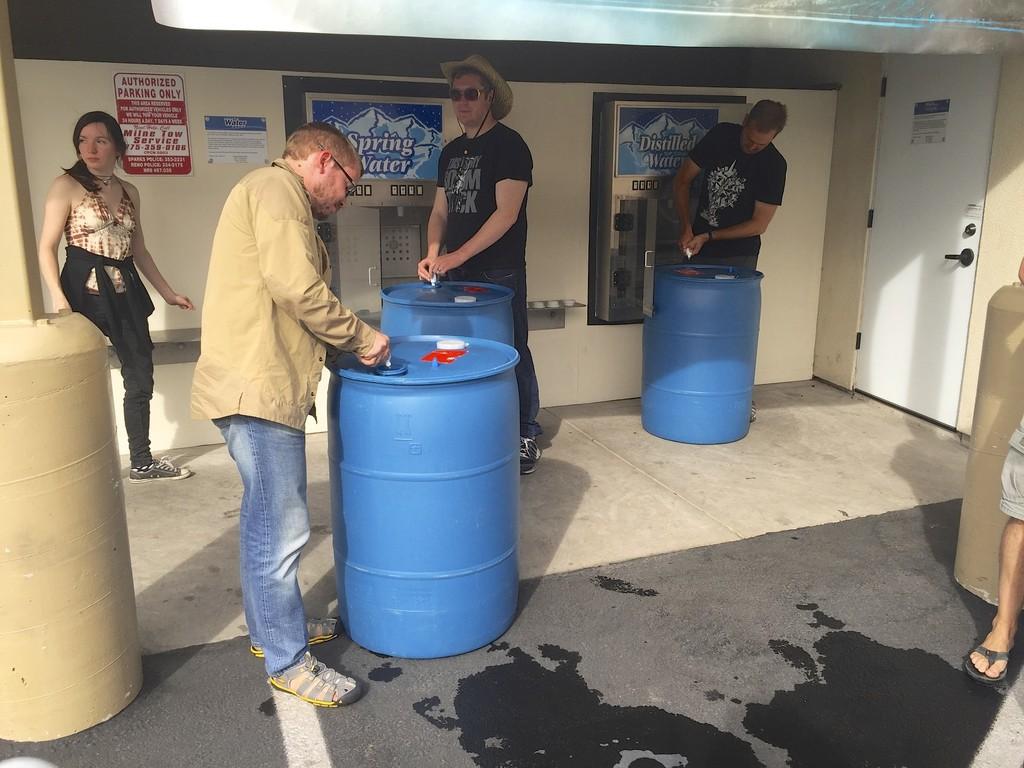What type of water are these people getting?
Make the answer very short. Spring. 